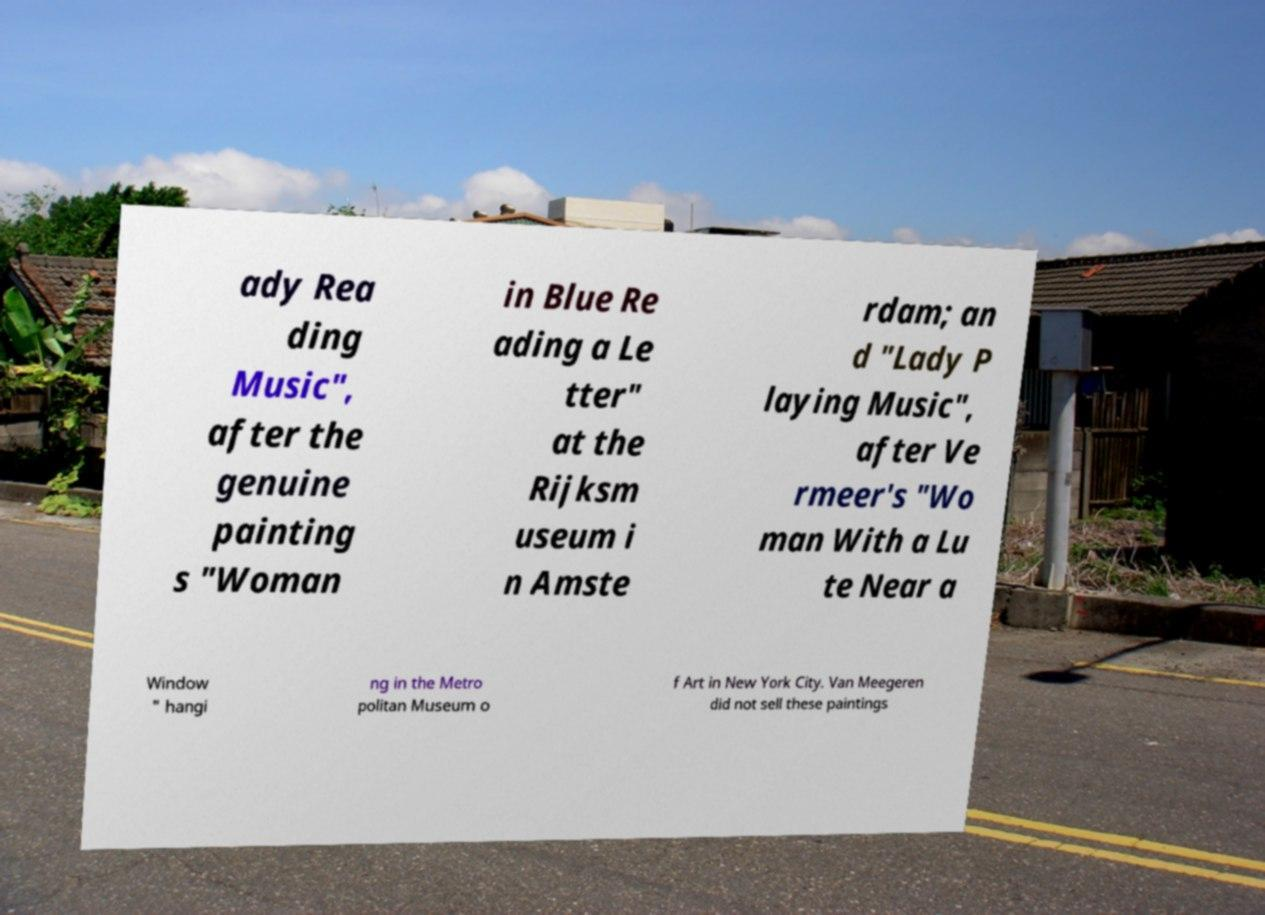There's text embedded in this image that I need extracted. Can you transcribe it verbatim? ady Rea ding Music", after the genuine painting s "Woman in Blue Re ading a Le tter" at the Rijksm useum i n Amste rdam; an d "Lady P laying Music", after Ve rmeer's "Wo man With a Lu te Near a Window " hangi ng in the Metro politan Museum o f Art in New York City. Van Meegeren did not sell these paintings 